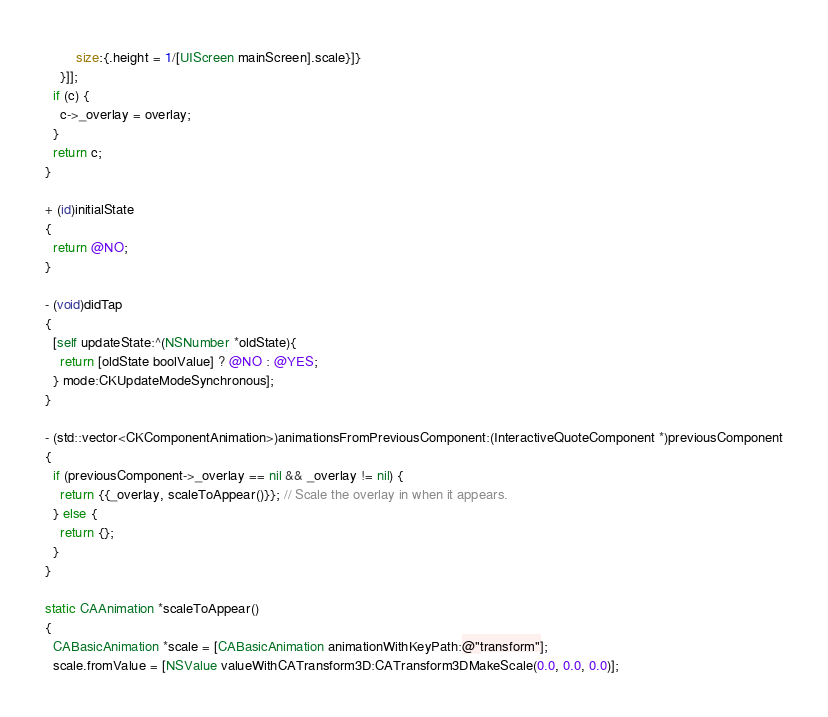<code> <loc_0><loc_0><loc_500><loc_500><_ObjectiveC_>        size:{.height = 1/[UIScreen mainScreen].scale}]}
    }]];
  if (c) {
    c->_overlay = overlay;
  }
  return c;
}

+ (id)initialState
{
  return @NO;
}

- (void)didTap
{
  [self updateState:^(NSNumber *oldState){
    return [oldState boolValue] ? @NO : @YES;
  } mode:CKUpdateModeSynchronous];
}

- (std::vector<CKComponentAnimation>)animationsFromPreviousComponent:(InteractiveQuoteComponent *)previousComponent
{
  if (previousComponent->_overlay == nil && _overlay != nil) {
    return {{_overlay, scaleToAppear()}}; // Scale the overlay in when it appears.
  } else {
    return {};
  }
}

static CAAnimation *scaleToAppear()
{
  CABasicAnimation *scale = [CABasicAnimation animationWithKeyPath:@"transform"];
  scale.fromValue = [NSValue valueWithCATransform3D:CATransform3DMakeScale(0.0, 0.0, 0.0)];</code> 